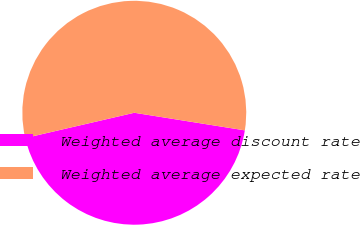<chart> <loc_0><loc_0><loc_500><loc_500><pie_chart><fcel>Weighted average discount rate<fcel>Weighted average expected rate<nl><fcel>43.86%<fcel>56.14%<nl></chart> 